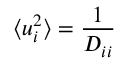<formula> <loc_0><loc_0><loc_500><loc_500>\langle u _ { i } ^ { 2 } \rangle = \frac { 1 } { D _ { i i } }</formula> 